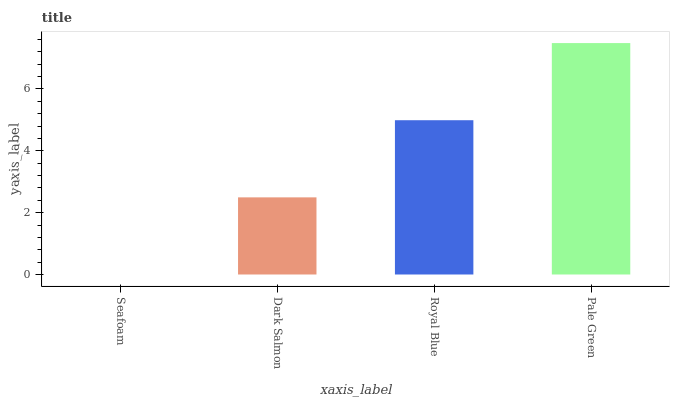Is Seafoam the minimum?
Answer yes or no. Yes. Is Pale Green the maximum?
Answer yes or no. Yes. Is Dark Salmon the minimum?
Answer yes or no. No. Is Dark Salmon the maximum?
Answer yes or no. No. Is Dark Salmon greater than Seafoam?
Answer yes or no. Yes. Is Seafoam less than Dark Salmon?
Answer yes or no. Yes. Is Seafoam greater than Dark Salmon?
Answer yes or no. No. Is Dark Salmon less than Seafoam?
Answer yes or no. No. Is Royal Blue the high median?
Answer yes or no. Yes. Is Dark Salmon the low median?
Answer yes or no. Yes. Is Seafoam the high median?
Answer yes or no. No. Is Royal Blue the low median?
Answer yes or no. No. 